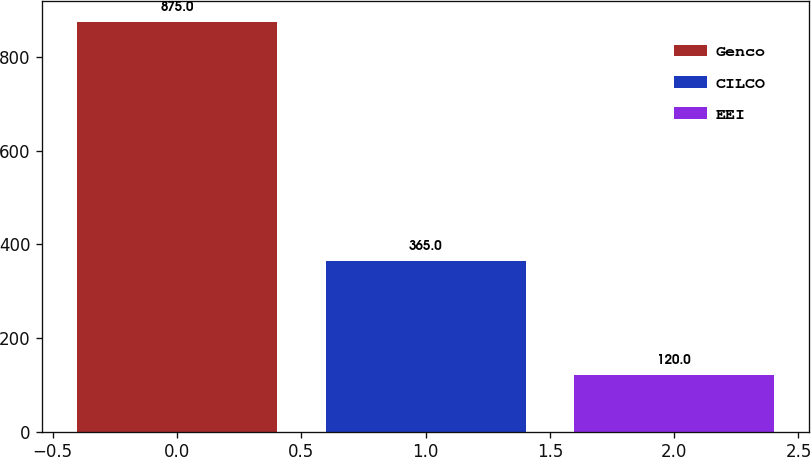<chart> <loc_0><loc_0><loc_500><loc_500><bar_chart><fcel>Genco<fcel>CILCO<fcel>EEI<nl><fcel>875<fcel>365<fcel>120<nl></chart> 